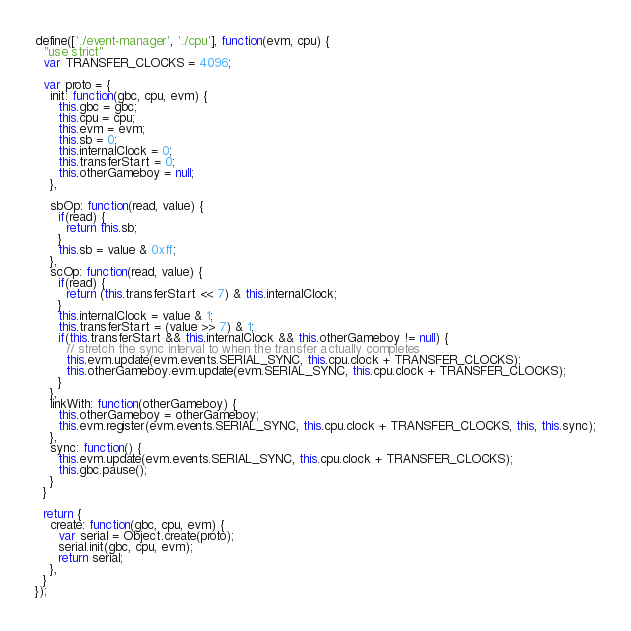Convert code to text. <code><loc_0><loc_0><loc_500><loc_500><_JavaScript_>define(['./event-manager', './cpu'], function(evm, cpu) {
  "use strict"
  var TRANSFER_CLOCKS = 4096;

  var proto = {
    init: function(gbc, cpu, evm) {
      this.gbc = gbc;
      this.cpu = cpu;
      this.evm = evm;
      this.sb = 0;
      this.internalClock = 0;
      this.transferStart = 0;
      this.otherGameboy = null;
    },

    sbOp: function(read, value) {
      if(read) {
        return this.sb;
      }
      this.sb = value & 0xff;
    },
    scOp: function(read, value) {
      if(read) {
        return (this.transferStart << 7) & this.internalClock;
      }
      this.internalClock = value & 1;
      this.transferStart = (value >> 7) & 1;
      if(this.transferStart && this.internalClock && this.otherGameboy != null) {
        // stretch the sync interval to when the transfer actually completes
        this.evm.update(evm.events.SERIAL_SYNC, this.cpu.clock + TRANSFER_CLOCKS);
        this.otherGameboy.evm.update(evm.SERIAL_SYNC, this.cpu.clock + TRANSFER_CLOCKS);
      }
    },
    linkWith: function(otherGameboy) {
      this.otherGameboy = otherGameboy;
      this.evm.register(evm.events.SERIAL_SYNC, this.cpu.clock + TRANSFER_CLOCKS, this, this.sync);
    },
    sync: function() {
      this.evm.update(evm.events.SERIAL_SYNC, this.cpu.clock + TRANSFER_CLOCKS);
      this.gbc.pause();
    }
  }

  return {
    create: function(gbc, cpu, evm) {
      var serial = Object.create(proto);
      serial.init(gbc, cpu, evm);
      return serial;
    },
  }
});
</code> 